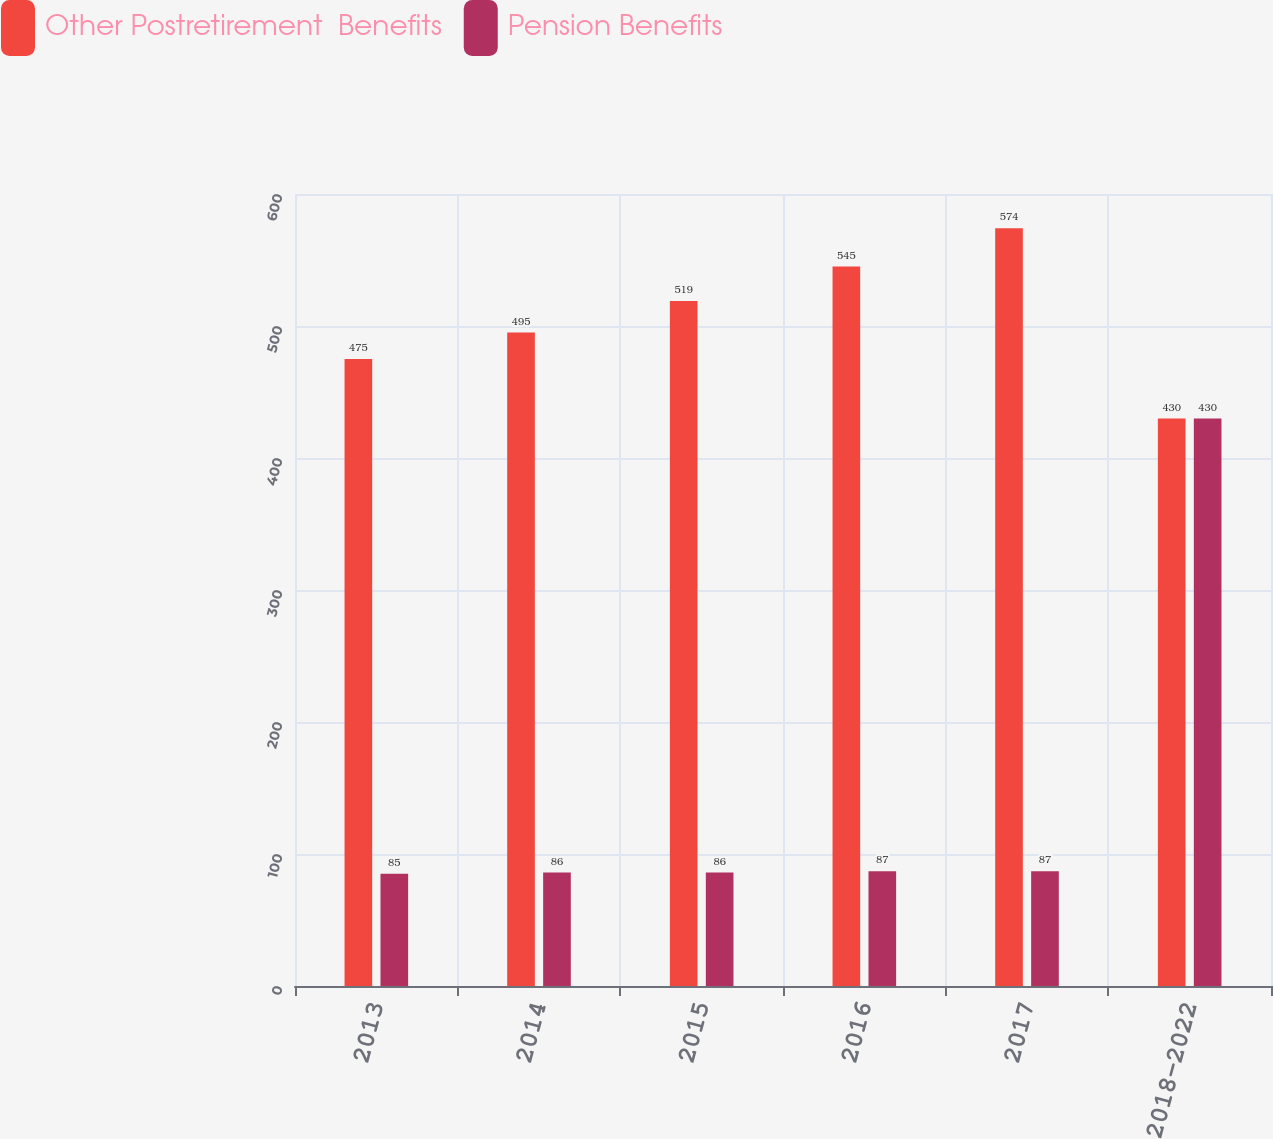<chart> <loc_0><loc_0><loc_500><loc_500><stacked_bar_chart><ecel><fcel>2013<fcel>2014<fcel>2015<fcel>2016<fcel>2017<fcel>2018-2022<nl><fcel>Other Postretirement  Benefits<fcel>475<fcel>495<fcel>519<fcel>545<fcel>574<fcel>430<nl><fcel>Pension Benefits<fcel>85<fcel>86<fcel>86<fcel>87<fcel>87<fcel>430<nl></chart> 